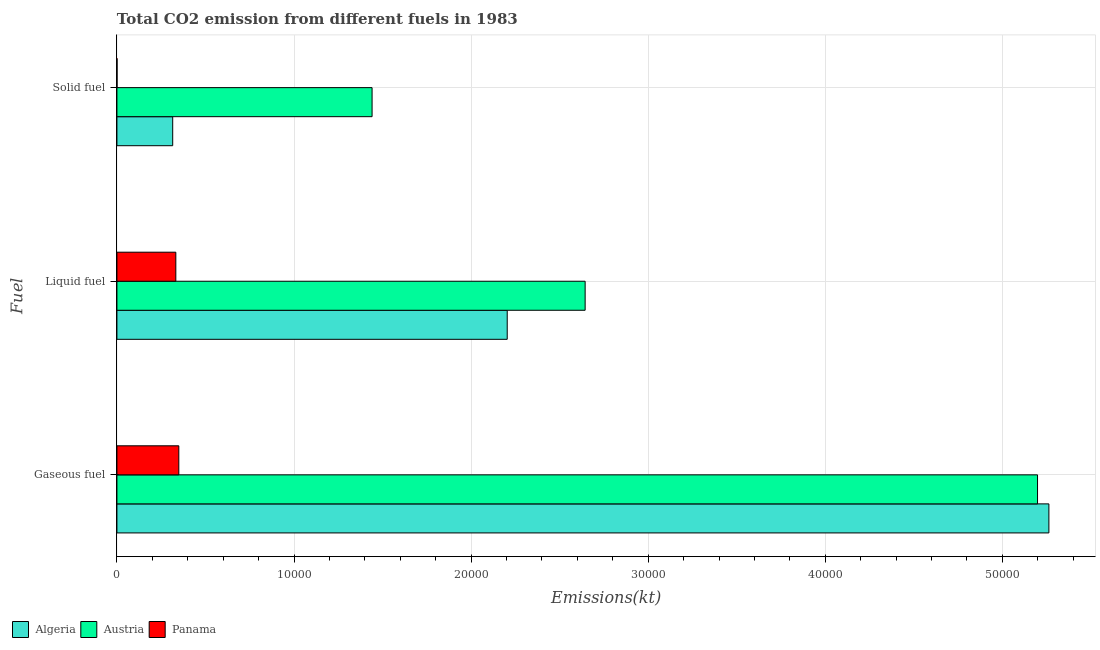How many different coloured bars are there?
Your response must be concise. 3. Are the number of bars on each tick of the Y-axis equal?
Your response must be concise. Yes. How many bars are there on the 1st tick from the top?
Make the answer very short. 3. How many bars are there on the 1st tick from the bottom?
Keep it short and to the point. 3. What is the label of the 3rd group of bars from the top?
Offer a very short reply. Gaseous fuel. What is the amount of co2 emissions from gaseous fuel in Austria?
Give a very brief answer. 5.20e+04. Across all countries, what is the maximum amount of co2 emissions from solid fuel?
Your response must be concise. 1.44e+04. Across all countries, what is the minimum amount of co2 emissions from liquid fuel?
Provide a succinct answer. 3325.97. In which country was the amount of co2 emissions from liquid fuel minimum?
Offer a very short reply. Panama. What is the total amount of co2 emissions from gaseous fuel in the graph?
Your answer should be very brief. 1.08e+05. What is the difference between the amount of co2 emissions from liquid fuel in Austria and that in Algeria?
Keep it short and to the point. 4400.4. What is the difference between the amount of co2 emissions from liquid fuel in Algeria and the amount of co2 emissions from gaseous fuel in Austria?
Provide a succinct answer. -2.99e+04. What is the average amount of co2 emissions from gaseous fuel per country?
Offer a terse response. 3.60e+04. What is the difference between the amount of co2 emissions from gaseous fuel and amount of co2 emissions from solid fuel in Panama?
Make the answer very short. 3487.32. In how many countries, is the amount of co2 emissions from liquid fuel greater than 50000 kt?
Provide a succinct answer. 0. What is the ratio of the amount of co2 emissions from gaseous fuel in Austria to that in Algeria?
Offer a terse response. 0.99. Is the amount of co2 emissions from liquid fuel in Austria less than that in Panama?
Keep it short and to the point. No. What is the difference between the highest and the second highest amount of co2 emissions from solid fuel?
Offer a very short reply. 1.13e+04. What is the difference between the highest and the lowest amount of co2 emissions from solid fuel?
Provide a short and direct response. 1.44e+04. What does the 2nd bar from the top in Gaseous fuel represents?
Ensure brevity in your answer.  Austria. What does the 1st bar from the bottom in Solid fuel represents?
Provide a succinct answer. Algeria. How many bars are there?
Keep it short and to the point. 9. Are the values on the major ticks of X-axis written in scientific E-notation?
Offer a terse response. No. Where does the legend appear in the graph?
Ensure brevity in your answer.  Bottom left. How are the legend labels stacked?
Make the answer very short. Horizontal. What is the title of the graph?
Give a very brief answer. Total CO2 emission from different fuels in 1983. What is the label or title of the X-axis?
Your answer should be very brief. Emissions(kt). What is the label or title of the Y-axis?
Provide a short and direct response. Fuel. What is the Emissions(kt) of Algeria in Gaseous fuel?
Provide a succinct answer. 5.26e+04. What is the Emissions(kt) of Austria in Gaseous fuel?
Provide a short and direct response. 5.20e+04. What is the Emissions(kt) of Panama in Gaseous fuel?
Offer a very short reply. 3494.65. What is the Emissions(kt) of Algeria in Liquid fuel?
Give a very brief answer. 2.20e+04. What is the Emissions(kt) in Austria in Liquid fuel?
Offer a terse response. 2.64e+04. What is the Emissions(kt) in Panama in Liquid fuel?
Offer a terse response. 3325.97. What is the Emissions(kt) in Algeria in Solid fuel?
Make the answer very short. 3149.95. What is the Emissions(kt) of Austria in Solid fuel?
Keep it short and to the point. 1.44e+04. What is the Emissions(kt) of Panama in Solid fuel?
Your answer should be very brief. 7.33. Across all Fuel, what is the maximum Emissions(kt) in Algeria?
Make the answer very short. 5.26e+04. Across all Fuel, what is the maximum Emissions(kt) of Austria?
Offer a terse response. 5.20e+04. Across all Fuel, what is the maximum Emissions(kt) of Panama?
Provide a succinct answer. 3494.65. Across all Fuel, what is the minimum Emissions(kt) in Algeria?
Provide a short and direct response. 3149.95. Across all Fuel, what is the minimum Emissions(kt) of Austria?
Ensure brevity in your answer.  1.44e+04. Across all Fuel, what is the minimum Emissions(kt) in Panama?
Your answer should be compact. 7.33. What is the total Emissions(kt) in Algeria in the graph?
Give a very brief answer. 7.78e+04. What is the total Emissions(kt) of Austria in the graph?
Offer a terse response. 9.28e+04. What is the total Emissions(kt) of Panama in the graph?
Make the answer very short. 6827.95. What is the difference between the Emissions(kt) in Algeria in Gaseous fuel and that in Liquid fuel?
Your response must be concise. 3.06e+04. What is the difference between the Emissions(kt) of Austria in Gaseous fuel and that in Liquid fuel?
Provide a succinct answer. 2.55e+04. What is the difference between the Emissions(kt) of Panama in Gaseous fuel and that in Liquid fuel?
Keep it short and to the point. 168.68. What is the difference between the Emissions(kt) in Algeria in Gaseous fuel and that in Solid fuel?
Provide a short and direct response. 4.95e+04. What is the difference between the Emissions(kt) in Austria in Gaseous fuel and that in Solid fuel?
Your answer should be very brief. 3.76e+04. What is the difference between the Emissions(kt) in Panama in Gaseous fuel and that in Solid fuel?
Your answer should be very brief. 3487.32. What is the difference between the Emissions(kt) of Algeria in Liquid fuel and that in Solid fuel?
Ensure brevity in your answer.  1.89e+04. What is the difference between the Emissions(kt) of Austria in Liquid fuel and that in Solid fuel?
Your response must be concise. 1.20e+04. What is the difference between the Emissions(kt) of Panama in Liquid fuel and that in Solid fuel?
Make the answer very short. 3318.64. What is the difference between the Emissions(kt) of Algeria in Gaseous fuel and the Emissions(kt) of Austria in Liquid fuel?
Offer a terse response. 2.62e+04. What is the difference between the Emissions(kt) in Algeria in Gaseous fuel and the Emissions(kt) in Panama in Liquid fuel?
Your response must be concise. 4.93e+04. What is the difference between the Emissions(kt) in Austria in Gaseous fuel and the Emissions(kt) in Panama in Liquid fuel?
Offer a very short reply. 4.87e+04. What is the difference between the Emissions(kt) of Algeria in Gaseous fuel and the Emissions(kt) of Austria in Solid fuel?
Your answer should be compact. 3.82e+04. What is the difference between the Emissions(kt) in Algeria in Gaseous fuel and the Emissions(kt) in Panama in Solid fuel?
Ensure brevity in your answer.  5.26e+04. What is the difference between the Emissions(kt) in Austria in Gaseous fuel and the Emissions(kt) in Panama in Solid fuel?
Your answer should be very brief. 5.20e+04. What is the difference between the Emissions(kt) of Algeria in Liquid fuel and the Emissions(kt) of Austria in Solid fuel?
Ensure brevity in your answer.  7631.03. What is the difference between the Emissions(kt) in Algeria in Liquid fuel and the Emissions(kt) in Panama in Solid fuel?
Your answer should be compact. 2.20e+04. What is the difference between the Emissions(kt) of Austria in Liquid fuel and the Emissions(kt) of Panama in Solid fuel?
Your response must be concise. 2.64e+04. What is the average Emissions(kt) of Algeria per Fuel?
Offer a very short reply. 2.59e+04. What is the average Emissions(kt) in Austria per Fuel?
Offer a terse response. 3.09e+04. What is the average Emissions(kt) of Panama per Fuel?
Keep it short and to the point. 2275.98. What is the difference between the Emissions(kt) of Algeria and Emissions(kt) of Austria in Gaseous fuel?
Your answer should be compact. 641.73. What is the difference between the Emissions(kt) in Algeria and Emissions(kt) in Panama in Gaseous fuel?
Give a very brief answer. 4.91e+04. What is the difference between the Emissions(kt) of Austria and Emissions(kt) of Panama in Gaseous fuel?
Keep it short and to the point. 4.85e+04. What is the difference between the Emissions(kt) of Algeria and Emissions(kt) of Austria in Liquid fuel?
Make the answer very short. -4400.4. What is the difference between the Emissions(kt) of Algeria and Emissions(kt) of Panama in Liquid fuel?
Provide a succinct answer. 1.87e+04. What is the difference between the Emissions(kt) of Austria and Emissions(kt) of Panama in Liquid fuel?
Keep it short and to the point. 2.31e+04. What is the difference between the Emissions(kt) of Algeria and Emissions(kt) of Austria in Solid fuel?
Ensure brevity in your answer.  -1.13e+04. What is the difference between the Emissions(kt) of Algeria and Emissions(kt) of Panama in Solid fuel?
Your response must be concise. 3142.62. What is the difference between the Emissions(kt) of Austria and Emissions(kt) of Panama in Solid fuel?
Your response must be concise. 1.44e+04. What is the ratio of the Emissions(kt) in Algeria in Gaseous fuel to that in Liquid fuel?
Offer a very short reply. 2.39. What is the ratio of the Emissions(kt) of Austria in Gaseous fuel to that in Liquid fuel?
Offer a terse response. 1.97. What is the ratio of the Emissions(kt) of Panama in Gaseous fuel to that in Liquid fuel?
Make the answer very short. 1.05. What is the ratio of the Emissions(kt) of Algeria in Gaseous fuel to that in Solid fuel?
Your answer should be very brief. 16.71. What is the ratio of the Emissions(kt) in Austria in Gaseous fuel to that in Solid fuel?
Offer a terse response. 3.61. What is the ratio of the Emissions(kt) of Panama in Gaseous fuel to that in Solid fuel?
Provide a short and direct response. 476.5. What is the ratio of the Emissions(kt) in Algeria in Liquid fuel to that in Solid fuel?
Keep it short and to the point. 7. What is the ratio of the Emissions(kt) of Austria in Liquid fuel to that in Solid fuel?
Offer a terse response. 1.84. What is the ratio of the Emissions(kt) of Panama in Liquid fuel to that in Solid fuel?
Give a very brief answer. 453.5. What is the difference between the highest and the second highest Emissions(kt) in Algeria?
Ensure brevity in your answer.  3.06e+04. What is the difference between the highest and the second highest Emissions(kt) in Austria?
Offer a terse response. 2.55e+04. What is the difference between the highest and the second highest Emissions(kt) in Panama?
Make the answer very short. 168.68. What is the difference between the highest and the lowest Emissions(kt) in Algeria?
Ensure brevity in your answer.  4.95e+04. What is the difference between the highest and the lowest Emissions(kt) of Austria?
Provide a succinct answer. 3.76e+04. What is the difference between the highest and the lowest Emissions(kt) in Panama?
Provide a short and direct response. 3487.32. 